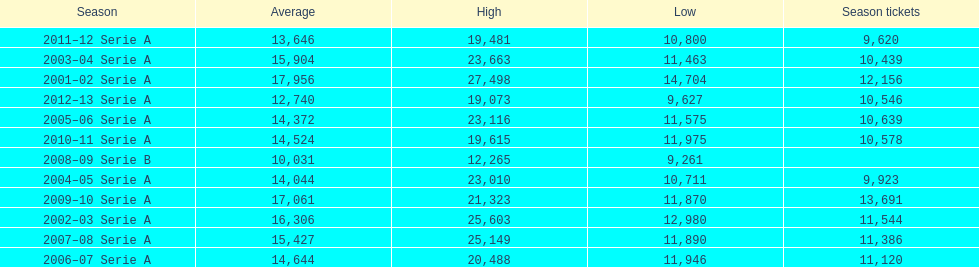How many seasons at the stadio ennio tardini had 11,000 or more season tickets? 5. 